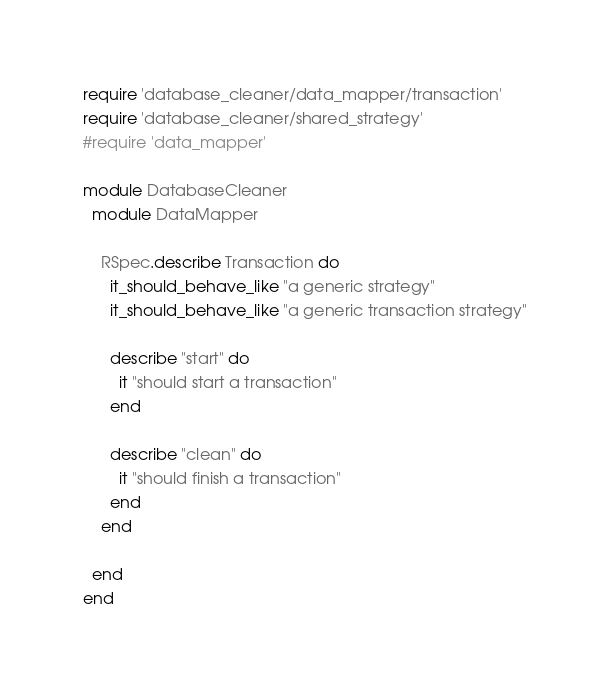<code> <loc_0><loc_0><loc_500><loc_500><_Ruby_>require 'database_cleaner/data_mapper/transaction'
require 'database_cleaner/shared_strategy'
#require 'data_mapper'

module DatabaseCleaner
  module DataMapper

    RSpec.describe Transaction do
      it_should_behave_like "a generic strategy"
      it_should_behave_like "a generic transaction strategy"

      describe "start" do
        it "should start a transaction"
      end

      describe "clean" do
        it "should finish a transaction"
      end
    end

  end
end
</code> 